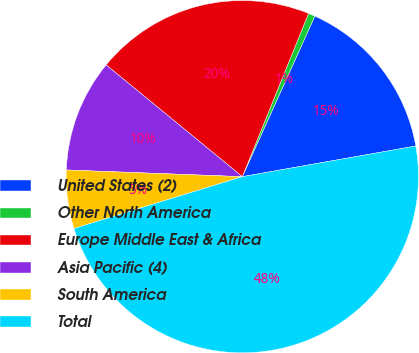<chart> <loc_0><loc_0><loc_500><loc_500><pie_chart><fcel>United States (2)<fcel>Other North America<fcel>Europe Middle East & Africa<fcel>Asia Pacific (4)<fcel>South America<fcel>Total<nl><fcel>15.46%<fcel>0.62%<fcel>20.2%<fcel>10.33%<fcel>5.36%<fcel>48.03%<nl></chart> 